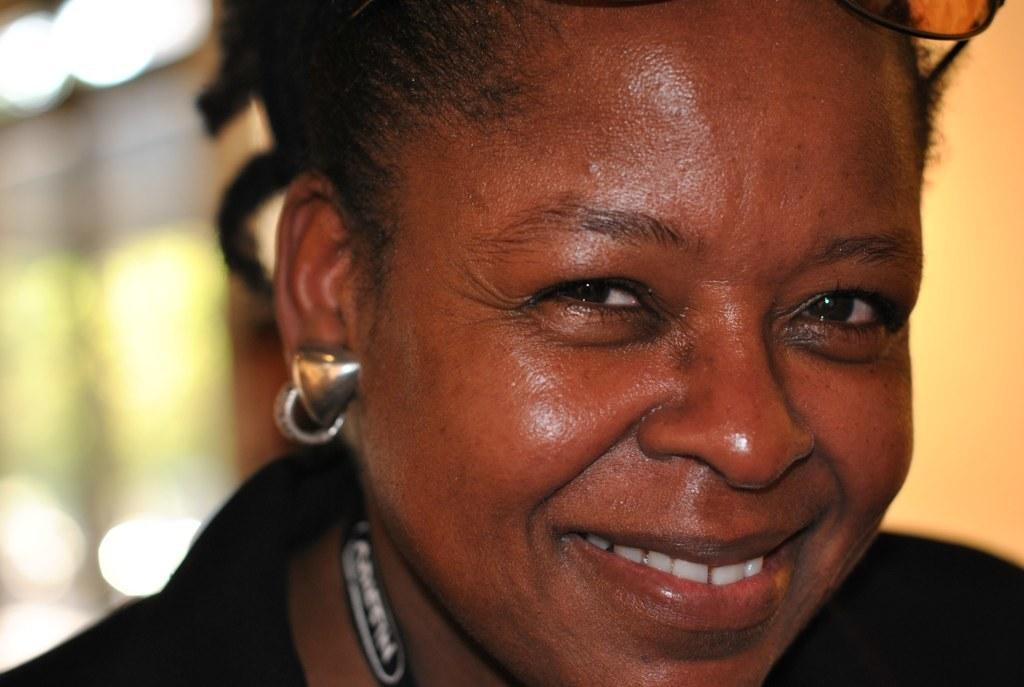What is the main subject of the image? The main subject of the image is a woman. What is the woman's facial expression in the image? The woman is smiling in the image. Can you describe the background of the image? The background of the image is blurry. How many apples is the expert holding in the image? There is no expert or apples present in the image. Is the boy in the image playing with a toy? There is no boy present in the image. 